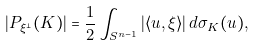Convert formula to latex. <formula><loc_0><loc_0><loc_500><loc_500>| P _ { \xi ^ { \perp } } ( K ) | = { \frac { 1 } { 2 } } \int _ { S ^ { n - 1 } } | \langle u , \xi \rangle | \, d \sigma _ { K } ( u ) ,</formula> 